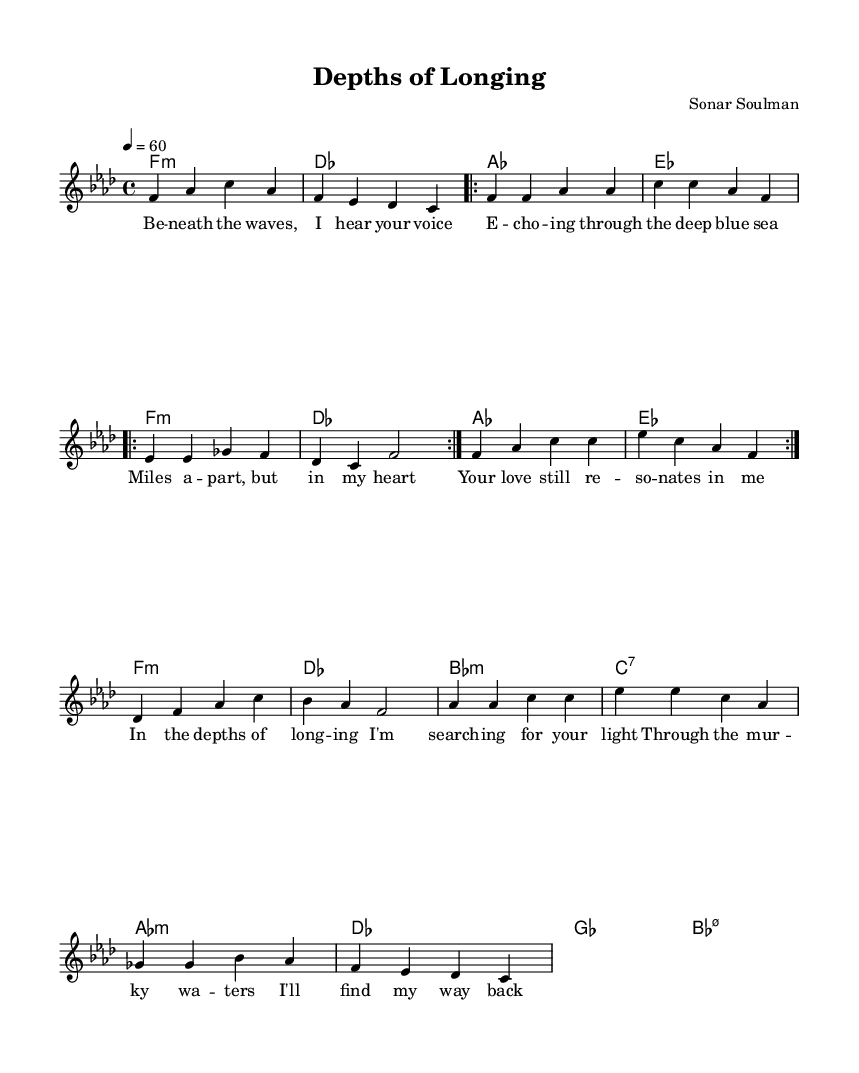What is the key signature of this music? The key signature is indicated at the beginning of the score. Here, it shows one flat (B♭) and four flats (B♭, E♭, A♭, D♭), which identifies the key as F minor.
Answer: F minor What is the time signature? The time signature is found at the start of the score, indicated by the numbers shown together. Here, it shows a four on the top and a four on the bottom, which means each measure contains four beats and the quarter note gets the beat.
Answer: Four four What is the tempo marking for this piece? The tempo marking is listed within the score and specifies the speed of the music. It states "4 = 60," meaning there are 60 beats per minute, indicating a moderate and steady pace.
Answer: Sixty How many times is the verse repeated? The lyrics indicate that the verse section is marked to be repeated twice. This is shown by the "repeat volta 2" notation in the melody section.
Answer: Two What vocal range does the melody primarily stay within? By analyzing the melody line shown, it mainly remains in the lower to middle range, peaking around the pitch of C and not going significantly higher than A♭. Thus, it suggests a soulful vocal execution typical for Rhythm and Blues ballads.
Answer: Middle range What emotions are conveyed through the lyrics of the chorus? The chorus expresses a sense of longing and hope as the narrator searches for light and connection amid the depths of missiness, which aligns with the emotional depth often found in Rhythm and Blues.
Answer: Longing and hope 